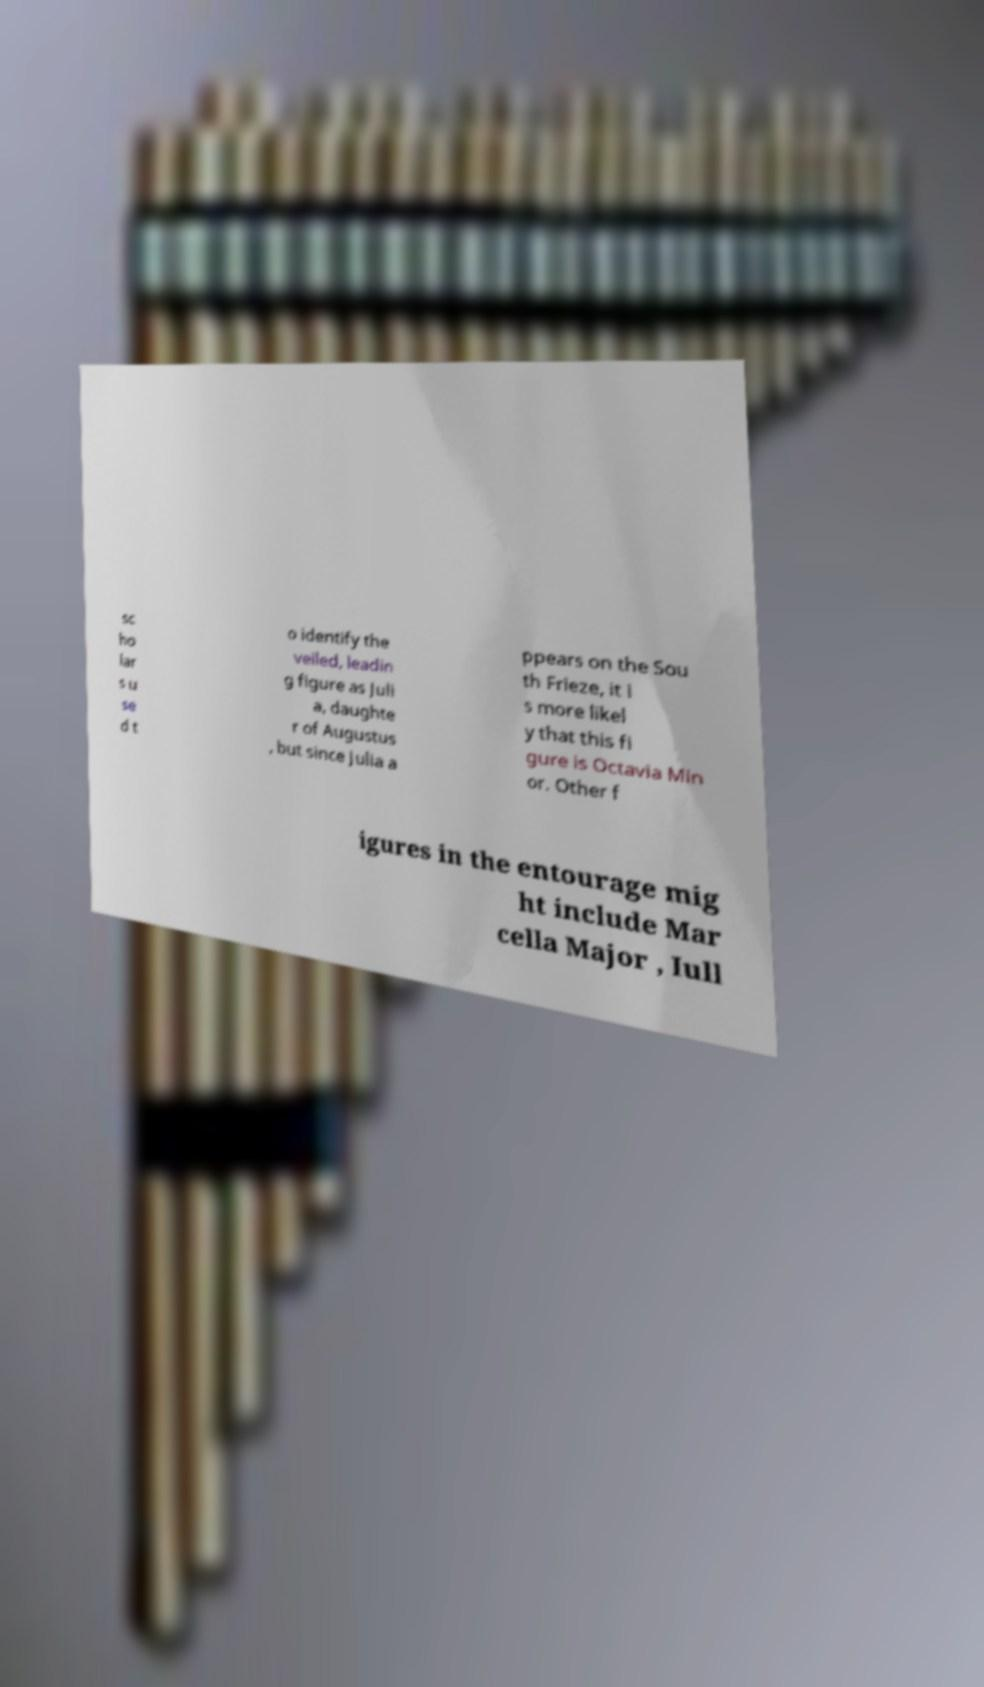I need the written content from this picture converted into text. Can you do that? sc ho lar s u se d t o identify the veiled, leadin g figure as Juli a, daughte r of Augustus , but since Julia a ppears on the Sou th Frieze, it i s more likel y that this fi gure is Octavia Min or. Other f igures in the entourage mig ht include Mar cella Major , Iull 